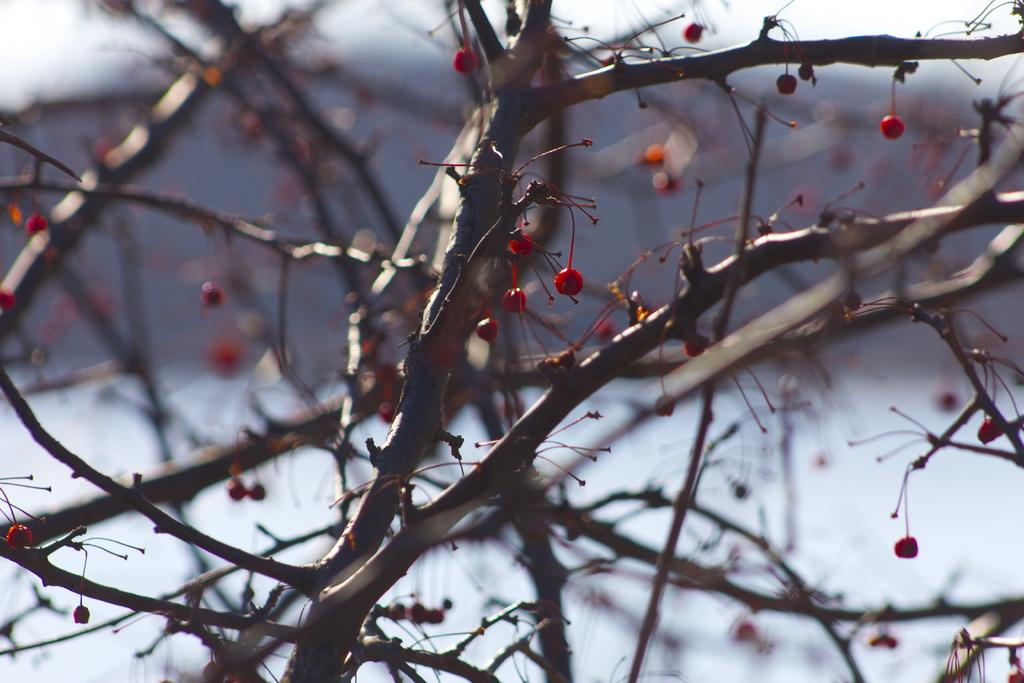What is the main object in the image? There is a tree in the image. Can you describe the background of the image? The background of the image is blurry. What type of polish is being applied to the car in the image? There is no car or polish present in the image; it only features a tree and a blurry background. 